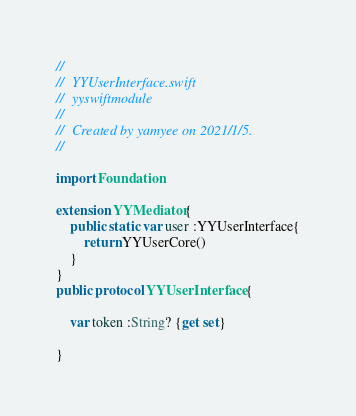<code> <loc_0><loc_0><loc_500><loc_500><_Swift_>//
//  YYUserInterface.swift
//  yyswiftmodule
//
//  Created by yamyee on 2021/1/5.
//

import Foundation

extension YYMediator{
    public static var user :YYUserInterface{
        return YYUserCore()
    }
}
public protocol YYUserInterface {
    
    var token :String? {get set}

}
</code> 